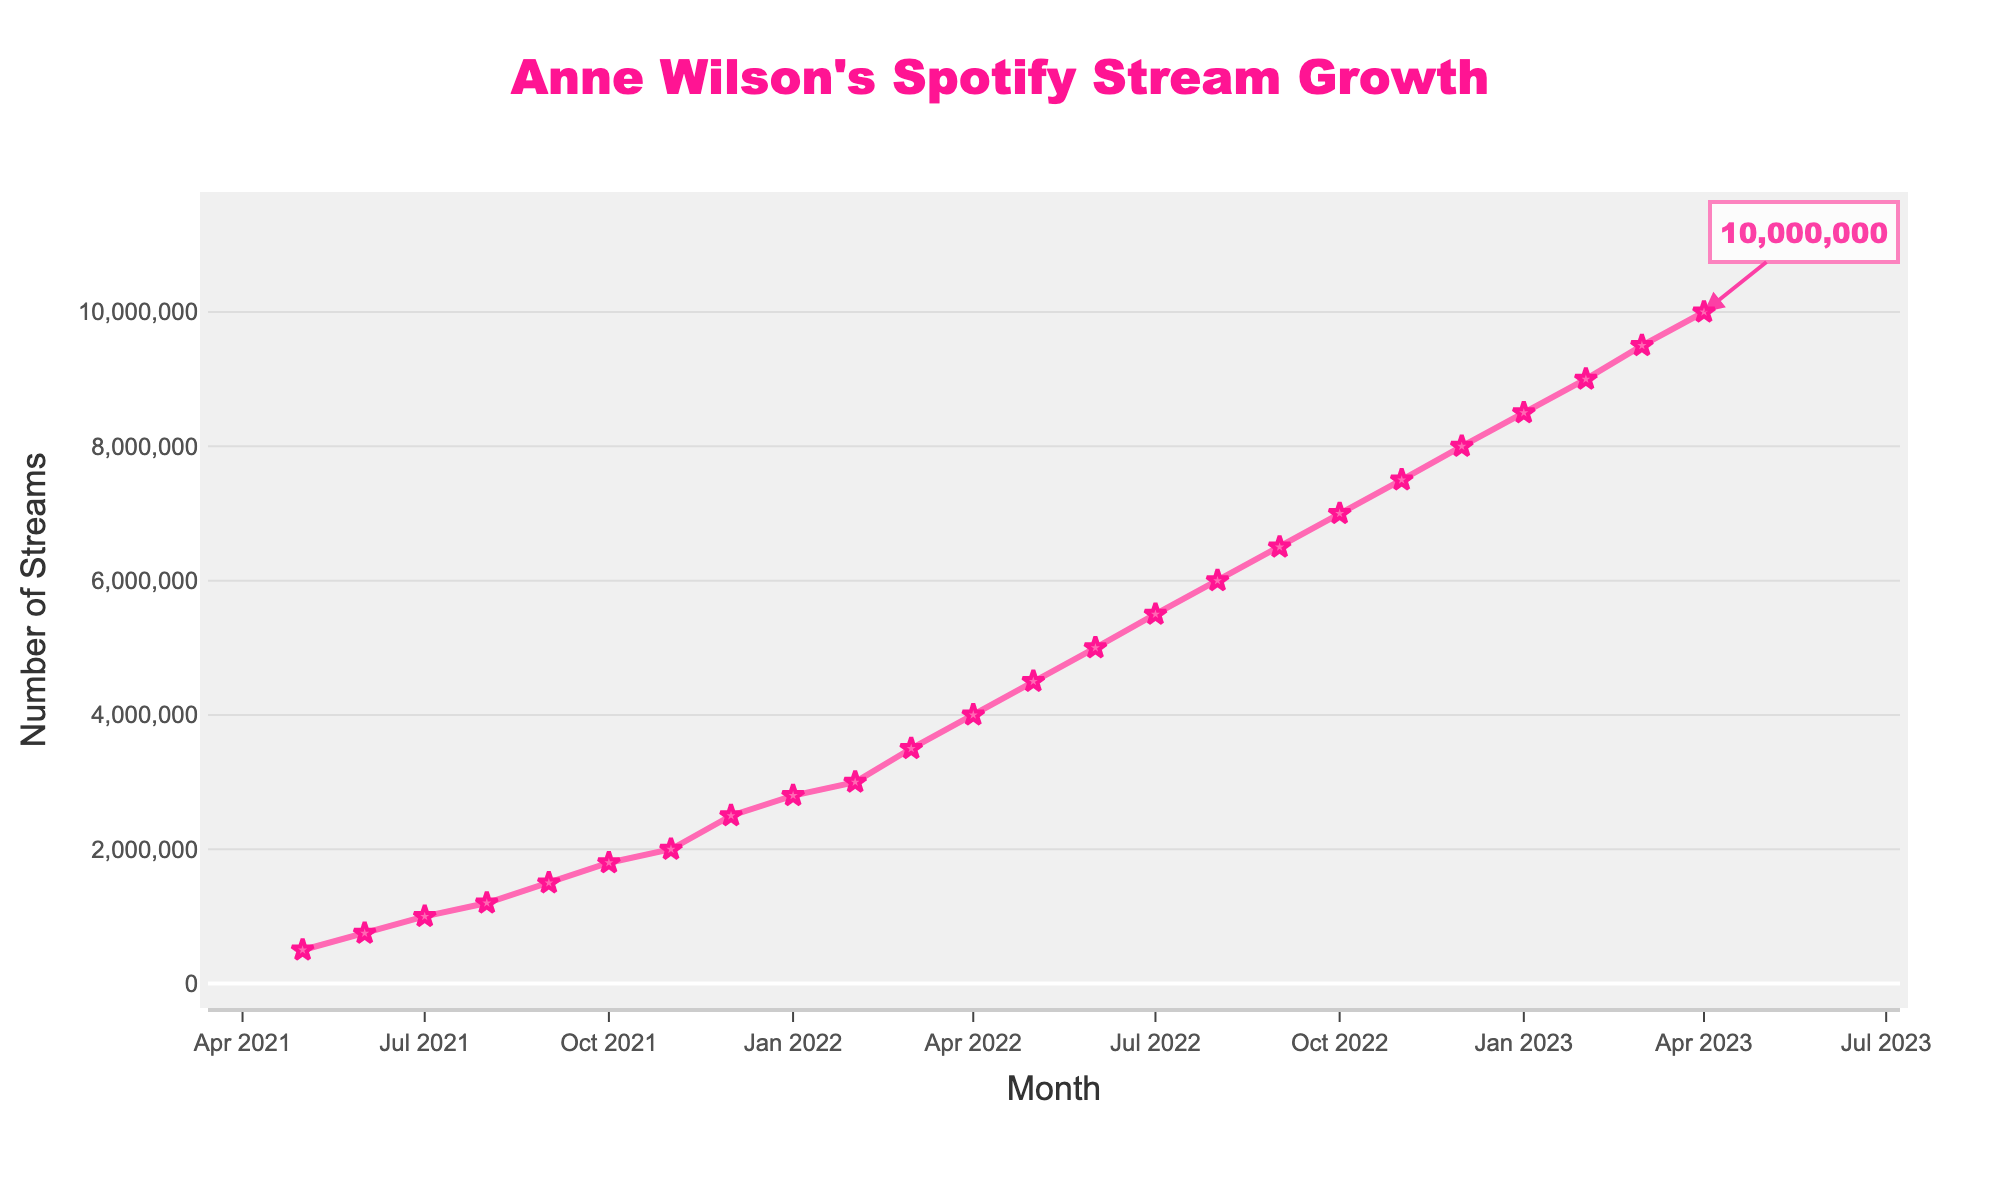What is the number of streams for Anne Wilson in December 2021? In December 2021, the line chart shows a point where the streams have increased. In the y-axis, we can see this increase reaches up to 2,500,000.
Answer: 2,500,000 How did the number of streams change from May 2021 to May 2022? In May 2021, the streams are at 500,000. By May 2022, the streams are at 4,500,000. The increase is calculated by subtracting the initial value from the final value: 4,500,000 - 500,000 = 4,000,000.
Answer: 4,000,000 By how many streams did Anne Wilson’s popularity grow from July 2021 to January 2023? In July 2021, the streams were at 1,000,000. By January 2023, they reached 8,500,000. The growth in streams is 8,500,000 - 1,000,000 = 7,500,000.
Answer: 7,500,000 Which month had the highest number of Spotify streams? The highest point on the y-axis and the rightmost point on the x-axis representing April 2023, with the number of streams at 10,000,000.
Answer: April 2023 What is the average number of streams from October 2021 to March 2022? The number of streams from October 2021 to March 2022 are 1,800,000, 2,000,000, 2,500,000, 2,800,000, 3,000,000, and 3,500,000. The sum is 15,600,000. Dividing by the number of months (6), we get 15,600,000 / 6 = 2,600,000.
Answer: 2,600,000 How many months did it take for Anne Wilson’s streams to double from her initial number in May 2021? In May 2021, the number of streams is at 500,000. Doubling that would be 1,000,000. This occurs in July 2021. From May to July, it is a span of 2 months.
Answer: 2 months Compare the growth in streams between the first six months and the last six months of the data. In the first six months (May 2021 to October 2021), streams grew from 500,000 to 1,800,000, which is an increase of 1,300,000. In the last six months (November 2022 to April 2023), streams grew from 7,500,000 to 10,000,000, which is an increase of 2,500,000.
Answer: Increase of 1,300,000 vs. increase of 2,500,000 What was the trend in the number of Spotify streams between November 2021 and February 2022? From November 2021 to February 2022, the number of streams increased every month. November 2021 had 2,000,000 streams, December 2021 had 2,500,000, January 2022 had 2,800,000, and February 2022 had 3,000,000, showing a consistent upward trend.
Answer: Upward trend 